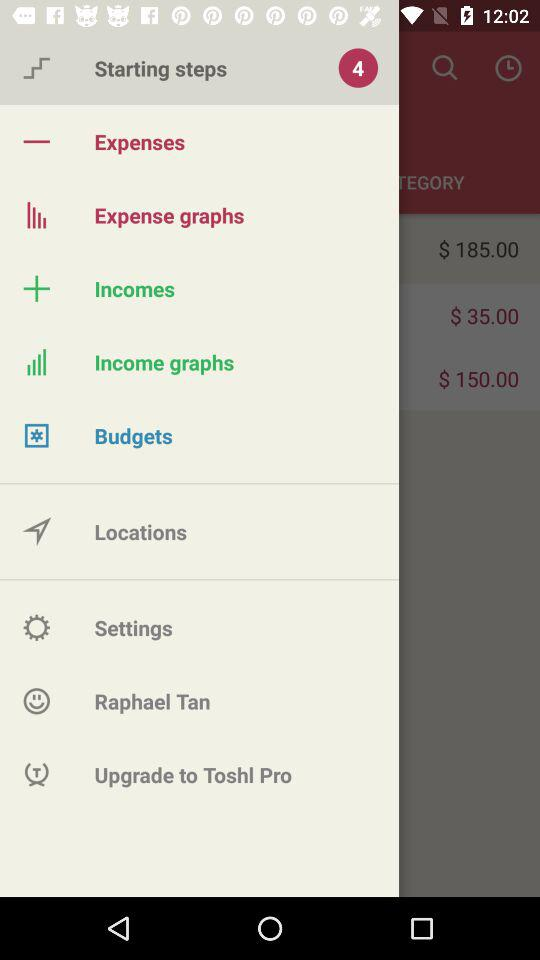How much more is the amount in the income graph than the amount in the expense graph?
Answer the question using a single word or phrase. $150.00 